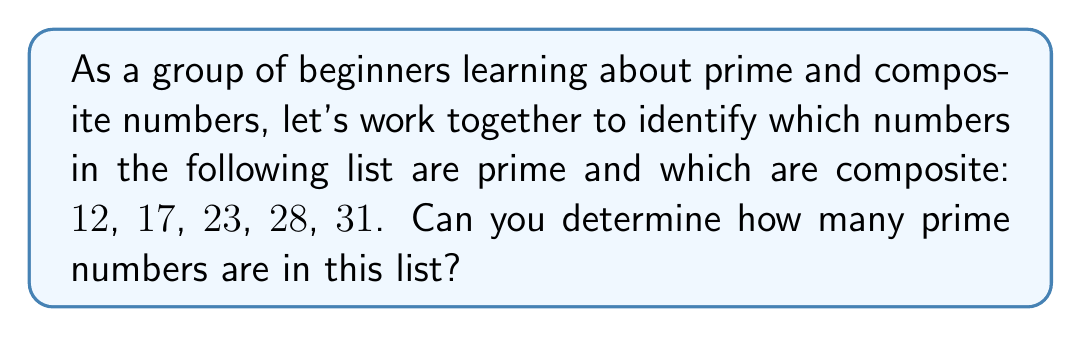Solve this math problem. Let's approach this step-by-step:

1) First, let's recall the definitions:
   - A prime number is a number greater than 1 that has exactly two factors: 1 and itself.
   - A composite number is a number greater than 1 that has more than two factors.

2) Now, let's examine each number:

   $12$: 
   - Factors: 1, 2, 3, 4, 6, 12
   - Conclusion: Composite (more than two factors)

   $17$:
   - Factors: 1, 17
   - Conclusion: Prime (only two factors)

   $23$:
   - Factors: 1, 23
   - Conclusion: Prime (only two factors)

   $28$:
   - Factors: 1, 2, 4, 7, 14, 28
   - Conclusion: Composite (more than two factors)

   $31$:
   - Factors: 1, 31
   - Conclusion: Prime (only two factors)

3) Counting the prime numbers:
   We identified 17, 23, and 31 as prime numbers.

Therefore, there are 3 prime numbers in this list.
Answer: 3 